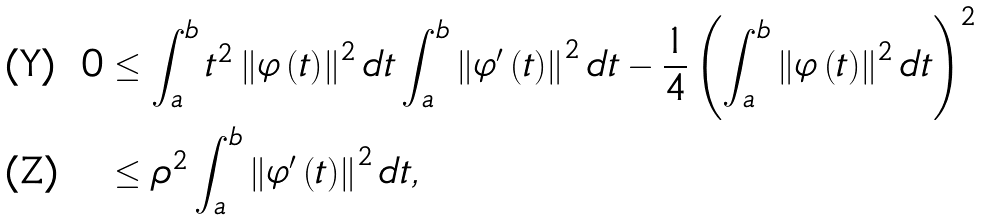Convert formula to latex. <formula><loc_0><loc_0><loc_500><loc_500>0 & \leq \int _ { a } ^ { b } t ^ { 2 } \left \| \varphi \left ( t \right ) \right \| ^ { 2 } d t \int _ { a } ^ { b } \left \| \varphi ^ { \prime } \left ( t \right ) \right \| ^ { 2 } d t - \frac { 1 } { 4 } \left ( \int _ { a } ^ { b } \left \| \varphi \left ( t \right ) \right \| ^ { 2 } d t \right ) ^ { 2 } \\ & \leq \rho ^ { 2 } \int _ { a } ^ { b } \left \| \varphi ^ { \prime } \left ( t \right ) \right \| ^ { 2 } d t ,</formula> 